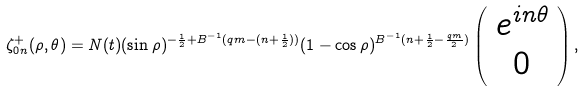<formula> <loc_0><loc_0><loc_500><loc_500>\zeta ^ { + } _ { 0 n } ( \rho , \theta ) = N ( t ) ( \sin \rho ) ^ { - \frac { 1 } { 2 } + B ^ { - 1 } ( q m - ( n + \frac { 1 } { 2 } ) ) } ( 1 - \cos \rho ) ^ { B ^ { - 1 } ( n + \frac { 1 } { 2 } - \frac { q m } { 2 } ) } \left ( \begin{array} { c } e ^ { i n \theta } \\ 0 \end{array} \right ) ,</formula> 